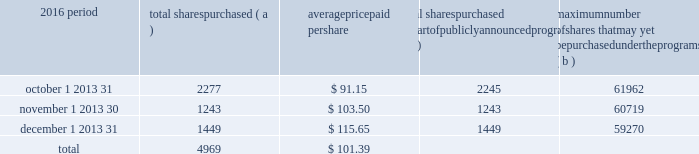Part ii item 5 2013 market for registrant 2019s common equity , related stockholder matters and issuer purchases of equity securities ( a ) ( 1 ) our common stock is listed on the new york stock exchange and is traded under the symbol 201cpnc . 201d at the close of business on february 16 , 2017 , there were 60763 common shareholders of record .
Holders of pnc common stock are entitled to receive dividends when declared by the board of directors out of funds legally available for this purpose .
Our board of directors may not pay or set apart dividends on the common stock until dividends for all past dividend periods on any series of outstanding preferred stock and certain outstanding capital securities issued by the parent company have been paid or declared and set apart for payment .
The board of directors presently intends to continue the policy of paying quarterly cash dividends .
The amount of any future dividends will depend on economic and market conditions , our financial condition and operating results , and other factors , including contractual restrictions and applicable government regulations and policies ( such as those relating to the ability of bank and non-bank subsidiaries to pay dividends to the parent company and regulatory capital limitations ) .
The amount of our dividend is also currently subject to the results of the supervisory assessment of capital adequacy and capital planning processes undertaken by the federal reserve and our primary bank regulators as part of the comprehensive capital analysis and review ( ccar ) process as described in the supervision and regulation section in item 1 of this report .
The federal reserve has the power to prohibit us from paying dividends without its approval .
For further information concerning dividend restrictions and other factors that could limit our ability to pay dividends , as well as restrictions on loans , dividends or advances from bank subsidiaries to the parent company , see the supervision and regulation section in item 1 , item 1a risk factors , the capital and liquidity management portion of the risk management section in item 7 , and note 10 borrowed funds , note 15 equity and note 18 regulatory matters in the notes to consolidated financial statements in item 8 of this report , which we include here by reference .
We include here by reference additional information relating to pnc common stock under the common stock prices/ dividends declared section in the statistical information ( unaudited ) section of item 8 of this report .
We include here by reference the information regarding our compensation plans under which pnc equity securities are authorized for issuance as of december 31 , 2016 in the table ( with introductory paragraph and notes ) that appears in item 12 of this report .
Our stock transfer agent and registrar is : computershare trust company , n.a .
250 royall street canton , ma 02021 800-982-7652 registered shareholders may contact this phone number regarding dividends and other shareholder services .
We include here by reference the information that appears under the common stock performance graph caption at the end of this item 5 .
( a ) ( 2 ) none .
( b ) not applicable .
( c ) details of our repurchases of pnc common stock during the fourth quarter of 2016 are included in the table : in thousands , except per share data 2016 period total shares purchased ( a ) average paid per total shares purchased as part of publicly announced programs ( b ) maximum number of shares that may yet be purchased under the programs ( b ) .
( a ) includes pnc common stock purchased in connection with our various employee benefit plans generally related to forfeitures of unvested restricted stock awards and shares used to cover employee payroll tax withholding requirements .
Note 11 employee benefit plans and note 12 stock based compensation plans in the notes to consolidated financial statements in item 8 of this report include additional information regarding our employee benefit and equity compensation plans that use pnc common stock .
( b ) on march 11 , 2015 , we announced that our board of directors approved the establishment of a stock repurchase program authorization in the amount of 100 million shares of pnc common stock , effective april 1 , 2015 .
Repurchases are made in open market or privately negotiated transactions and the timing and exact amount of common stock repurchases will depend on a number of factors including , among others , market and general economic conditions , regulatory capital considerations , alternative uses of capital , the potential impact on our credit ratings , and contractual and regulatory limitations , including the results of the supervisory assessment of capital adequacy and capital planning processes undertaken by the federal reserve as part of the ccar process .
In june 2016 , we announced share repurchase programs of up to $ 2.0 billion for the four quarter period beginning with the third quarter of 2016 , including repurchases of up to $ 200 million related to employee benefit plans .
In january 2017 , we announced a $ 300 million increase in our share repurchase programs for this period .
In the fourth quarter of 2016 , we repurchased 4.9 million shares of common stock on the open market , with an average price of $ 101.47 per share and an aggregate repurchase price of $ .5 billion .
See the liquidity and capital management portion of the risk management section in item 7 of this report for more information on the share repurchase programs under the share repurchase authorization for the period july 1 , 2016 through june 30 , 2017 included in the 2016 capital plan accepted by the federal reserve .
28 the pnc financial services group , inc .
2013 form 10-k .
For the fourth quarter of 2016 , what was the total amount spent to repurchase shares ( in thousands ) ?\\n? 
Computations: (4969 * 101.39)
Answer: 503806.91. Part ii item 5 2013 market for registrant 2019s common equity , related stockholder matters and issuer purchases of equity securities ( a ) ( 1 ) our common stock is listed on the new york stock exchange and is traded under the symbol 201cpnc . 201d at the close of business on february 16 , 2017 , there were 60763 common shareholders of record .
Holders of pnc common stock are entitled to receive dividends when declared by the board of directors out of funds legally available for this purpose .
Our board of directors may not pay or set apart dividends on the common stock until dividends for all past dividend periods on any series of outstanding preferred stock and certain outstanding capital securities issued by the parent company have been paid or declared and set apart for payment .
The board of directors presently intends to continue the policy of paying quarterly cash dividends .
The amount of any future dividends will depend on economic and market conditions , our financial condition and operating results , and other factors , including contractual restrictions and applicable government regulations and policies ( such as those relating to the ability of bank and non-bank subsidiaries to pay dividends to the parent company and regulatory capital limitations ) .
The amount of our dividend is also currently subject to the results of the supervisory assessment of capital adequacy and capital planning processes undertaken by the federal reserve and our primary bank regulators as part of the comprehensive capital analysis and review ( ccar ) process as described in the supervision and regulation section in item 1 of this report .
The federal reserve has the power to prohibit us from paying dividends without its approval .
For further information concerning dividend restrictions and other factors that could limit our ability to pay dividends , as well as restrictions on loans , dividends or advances from bank subsidiaries to the parent company , see the supervision and regulation section in item 1 , item 1a risk factors , the capital and liquidity management portion of the risk management section in item 7 , and note 10 borrowed funds , note 15 equity and note 18 regulatory matters in the notes to consolidated financial statements in item 8 of this report , which we include here by reference .
We include here by reference additional information relating to pnc common stock under the common stock prices/ dividends declared section in the statistical information ( unaudited ) section of item 8 of this report .
We include here by reference the information regarding our compensation plans under which pnc equity securities are authorized for issuance as of december 31 , 2016 in the table ( with introductory paragraph and notes ) that appears in item 12 of this report .
Our stock transfer agent and registrar is : computershare trust company , n.a .
250 royall street canton , ma 02021 800-982-7652 registered shareholders may contact this phone number regarding dividends and other shareholder services .
We include here by reference the information that appears under the common stock performance graph caption at the end of this item 5 .
( a ) ( 2 ) none .
( b ) not applicable .
( c ) details of our repurchases of pnc common stock during the fourth quarter of 2016 are included in the table : in thousands , except per share data 2016 period total shares purchased ( a ) average paid per total shares purchased as part of publicly announced programs ( b ) maximum number of shares that may yet be purchased under the programs ( b ) .
( a ) includes pnc common stock purchased in connection with our various employee benefit plans generally related to forfeitures of unvested restricted stock awards and shares used to cover employee payroll tax withholding requirements .
Note 11 employee benefit plans and note 12 stock based compensation plans in the notes to consolidated financial statements in item 8 of this report include additional information regarding our employee benefit and equity compensation plans that use pnc common stock .
( b ) on march 11 , 2015 , we announced that our board of directors approved the establishment of a stock repurchase program authorization in the amount of 100 million shares of pnc common stock , effective april 1 , 2015 .
Repurchases are made in open market or privately negotiated transactions and the timing and exact amount of common stock repurchases will depend on a number of factors including , among others , market and general economic conditions , regulatory capital considerations , alternative uses of capital , the potential impact on our credit ratings , and contractual and regulatory limitations , including the results of the supervisory assessment of capital adequacy and capital planning processes undertaken by the federal reserve as part of the ccar process .
In june 2016 , we announced share repurchase programs of up to $ 2.0 billion for the four quarter period beginning with the third quarter of 2016 , including repurchases of up to $ 200 million related to employee benefit plans .
In january 2017 , we announced a $ 300 million increase in our share repurchase programs for this period .
In the fourth quarter of 2016 , we repurchased 4.9 million shares of common stock on the open market , with an average price of $ 101.47 per share and an aggregate repurchase price of $ .5 billion .
See the liquidity and capital management portion of the risk management section in item 7 of this report for more information on the share repurchase programs under the share repurchase authorization for the period july 1 , 2016 through june 30 , 2017 included in the 2016 capital plan accepted by the federal reserve .
28 the pnc financial services group , inc .
2013 form 10-k .
For the period october 1 2013 31 , total shares purchased as part of publicly announced programs were what percent of total shares purchased? 
Computations: (2245 / 2277)
Answer: 0.98595. 